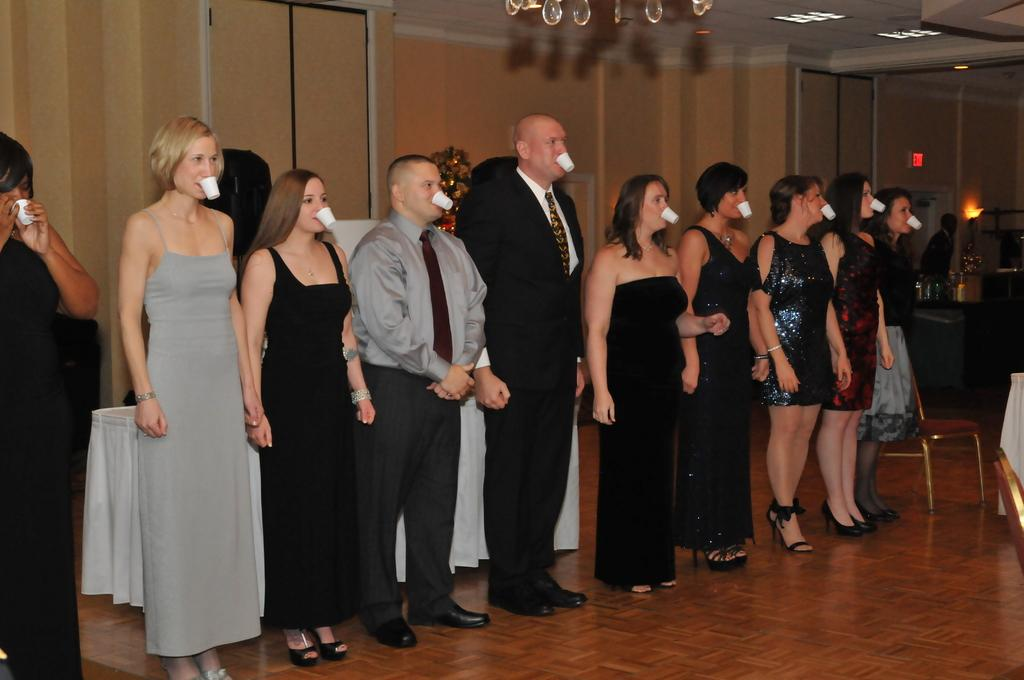What is the main subject of the image? There is a beautiful woman in the image. Where is the woman positioned in the image? The woman is standing on the left side. What is the woman doing with the cup in the image? The woman is holding a cup with her mouth. Are there any other people in the image? Yes, there are other people in the image. What are the other people doing in the image? The other people are also standing and holding cups with their mouths. What type of cactus can be seen in the background of the image? There is no cactus present in the image. What kind of structure is visible in the image? The image does not show any specific structure; it primarily features people holding cups with their mouths. 